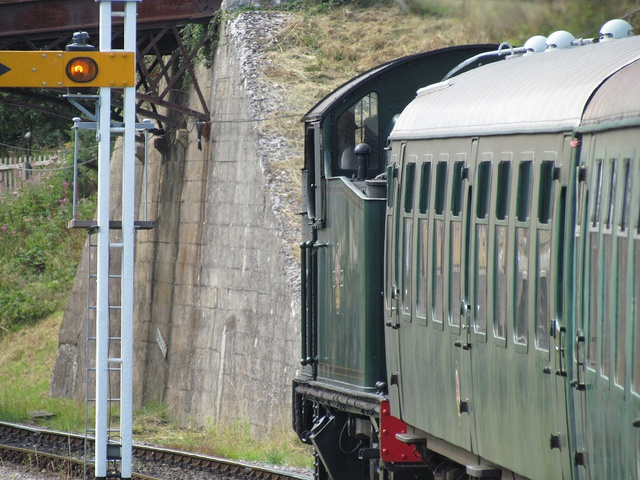Describe the objects in this image and their specific colors. I can see a train in black, gray, darkgray, and lightgray tones in this image. 